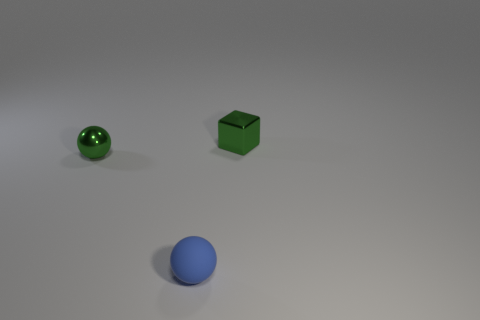Add 1 yellow metallic balls. How many objects exist? 4 Subtract all cubes. How many objects are left? 2 Subtract 0 gray cylinders. How many objects are left? 3 Subtract all small green metal things. Subtract all small cubes. How many objects are left? 0 Add 2 green things. How many green things are left? 4 Add 1 small brown matte cylinders. How many small brown matte cylinders exist? 1 